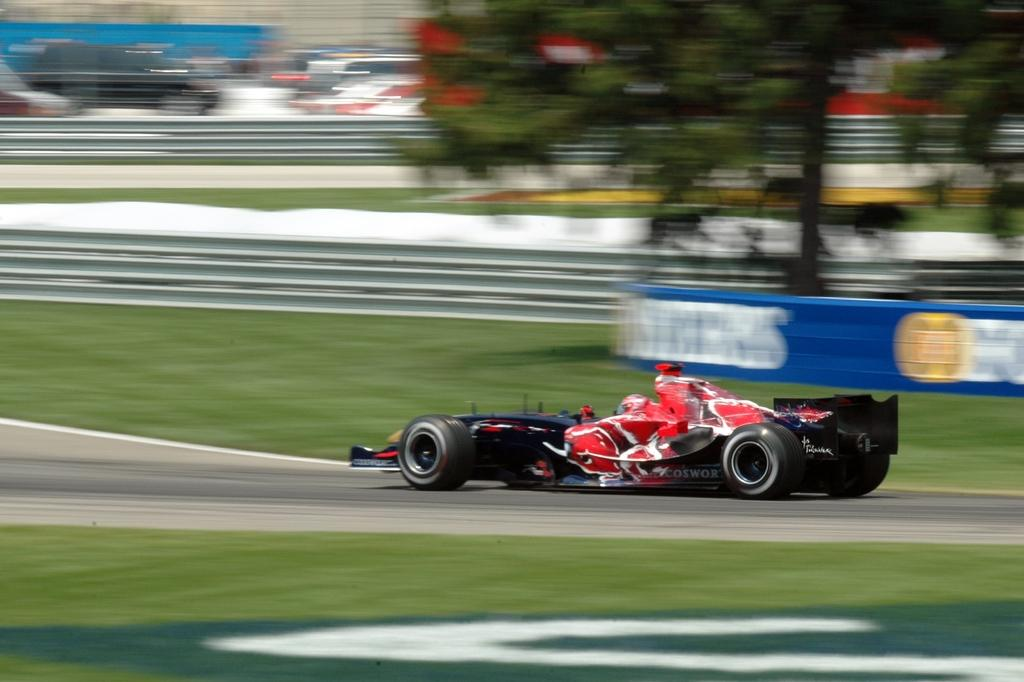What is the main subject of the image? There is a vehicle on the road in the image. What can be seen in the background of the image? There are trees, fences, and boards in the background of the image. Are there any other vehicles visible in the image? Yes, there are other vehicles visible in the background of the image. How many cats are sitting on the camera in the image? There are no cats or cameras present in the image. What type of stick is being used by the driver of the vehicle in the image? There is no stick visible in the image, and the driver's actions are not described. 